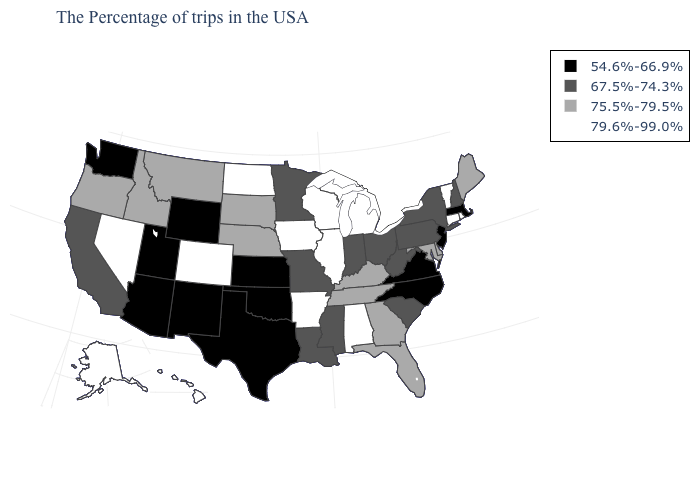What is the value of Pennsylvania?
Be succinct. 67.5%-74.3%. What is the value of North Dakota?
Keep it brief. 79.6%-99.0%. Name the states that have a value in the range 67.5%-74.3%?
Answer briefly. New Hampshire, New York, Pennsylvania, South Carolina, West Virginia, Ohio, Indiana, Mississippi, Louisiana, Missouri, Minnesota, California. What is the lowest value in states that border Florida?
Concise answer only. 75.5%-79.5%. Name the states that have a value in the range 75.5%-79.5%?
Answer briefly. Maine, Delaware, Maryland, Florida, Georgia, Kentucky, Tennessee, Nebraska, South Dakota, Montana, Idaho, Oregon. Does Illinois have the highest value in the MidWest?
Give a very brief answer. Yes. How many symbols are there in the legend?
Short answer required. 4. What is the value of Connecticut?
Give a very brief answer. 79.6%-99.0%. Name the states that have a value in the range 54.6%-66.9%?
Keep it brief. Massachusetts, New Jersey, Virginia, North Carolina, Kansas, Oklahoma, Texas, Wyoming, New Mexico, Utah, Arizona, Washington. Does New York have the lowest value in the Northeast?
Be succinct. No. Does Ohio have the highest value in the USA?
Answer briefly. No. What is the value of Louisiana?
Keep it brief. 67.5%-74.3%. What is the highest value in the West ?
Keep it brief. 79.6%-99.0%. Among the states that border Rhode Island , does Massachusetts have the highest value?
Give a very brief answer. No. Name the states that have a value in the range 67.5%-74.3%?
Answer briefly. New Hampshire, New York, Pennsylvania, South Carolina, West Virginia, Ohio, Indiana, Mississippi, Louisiana, Missouri, Minnesota, California. 